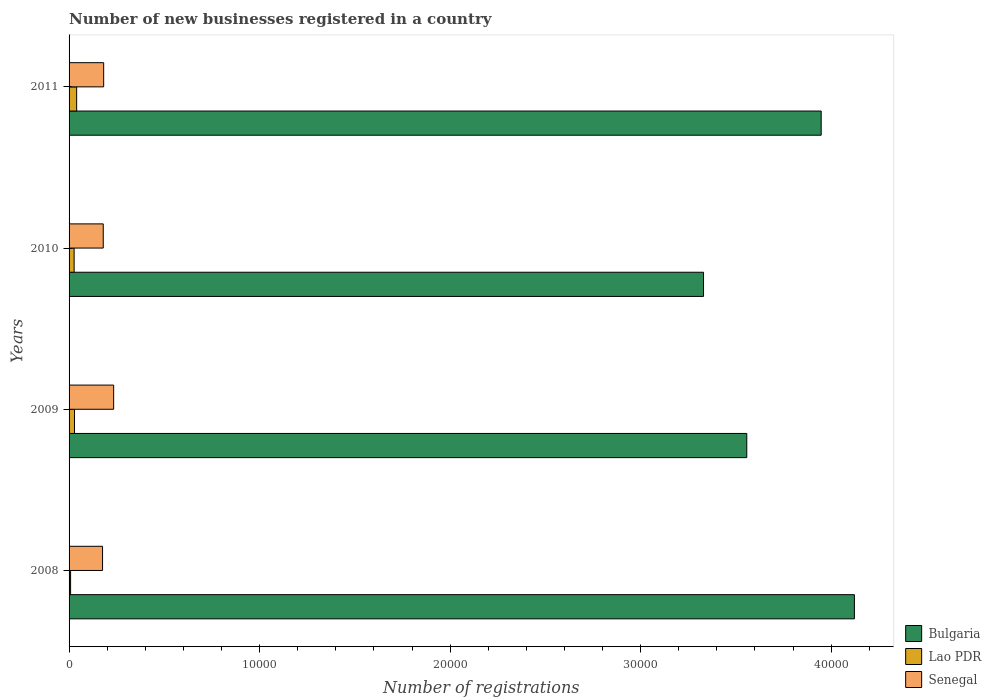How many different coloured bars are there?
Offer a very short reply. 3. How many groups of bars are there?
Your response must be concise. 4. Are the number of bars per tick equal to the number of legend labels?
Your answer should be very brief. Yes. Are the number of bars on each tick of the Y-axis equal?
Your answer should be compact. Yes. How many bars are there on the 2nd tick from the top?
Provide a short and direct response. 3. What is the label of the 3rd group of bars from the top?
Your answer should be compact. 2009. What is the number of new businesses registered in Lao PDR in 2010?
Provide a short and direct response. 265. Across all years, what is the maximum number of new businesses registered in Senegal?
Your answer should be very brief. 2340. In which year was the number of new businesses registered in Senegal maximum?
Ensure brevity in your answer.  2009. What is the total number of new businesses registered in Lao PDR in the graph?
Give a very brief answer. 1029. What is the difference between the number of new businesses registered in Senegal in 2008 and that in 2009?
Make the answer very short. -583. What is the difference between the number of new businesses registered in Bulgaria in 2010 and the number of new businesses registered in Senegal in 2008?
Offer a very short reply. 3.15e+04. What is the average number of new businesses registered in Bulgaria per year?
Your answer should be very brief. 3.74e+04. In the year 2009, what is the difference between the number of new businesses registered in Lao PDR and number of new businesses registered in Bulgaria?
Your answer should be compact. -3.53e+04. In how many years, is the number of new businesses registered in Bulgaria greater than 32000 ?
Make the answer very short. 4. What is the ratio of the number of new businesses registered in Lao PDR in 2008 to that in 2011?
Your answer should be compact. 0.2. Is the number of new businesses registered in Lao PDR in 2008 less than that in 2011?
Offer a very short reply. Yes. What is the difference between the highest and the second highest number of new businesses registered in Senegal?
Give a very brief answer. 524. What is the difference between the highest and the lowest number of new businesses registered in Bulgaria?
Ensure brevity in your answer.  7918. In how many years, is the number of new businesses registered in Bulgaria greater than the average number of new businesses registered in Bulgaria taken over all years?
Make the answer very short. 2. Is the sum of the number of new businesses registered in Senegal in 2010 and 2011 greater than the maximum number of new businesses registered in Bulgaria across all years?
Provide a succinct answer. No. What does the 2nd bar from the bottom in 2009 represents?
Your answer should be compact. Lao PDR. Is it the case that in every year, the sum of the number of new businesses registered in Lao PDR and number of new businesses registered in Senegal is greater than the number of new businesses registered in Bulgaria?
Make the answer very short. No. Are all the bars in the graph horizontal?
Make the answer very short. Yes. How many years are there in the graph?
Your response must be concise. 4. What is the difference between two consecutive major ticks on the X-axis?
Your answer should be very brief. 10000. Are the values on the major ticks of X-axis written in scientific E-notation?
Offer a terse response. No. Does the graph contain grids?
Keep it short and to the point. No. What is the title of the graph?
Your answer should be very brief. Number of new businesses registered in a country. What is the label or title of the X-axis?
Your answer should be very brief. Number of registrations. What is the Number of registrations of Bulgaria in 2008?
Offer a terse response. 4.12e+04. What is the Number of registrations of Senegal in 2008?
Make the answer very short. 1757. What is the Number of registrations in Bulgaria in 2009?
Ensure brevity in your answer.  3.56e+04. What is the Number of registrations of Lao PDR in 2009?
Offer a very short reply. 286. What is the Number of registrations of Senegal in 2009?
Ensure brevity in your answer.  2340. What is the Number of registrations in Bulgaria in 2010?
Your response must be concise. 3.33e+04. What is the Number of registrations in Lao PDR in 2010?
Provide a succinct answer. 265. What is the Number of registrations of Senegal in 2010?
Your response must be concise. 1794. What is the Number of registrations of Bulgaria in 2011?
Offer a very short reply. 3.95e+04. What is the Number of registrations of Lao PDR in 2011?
Your answer should be very brief. 398. What is the Number of registrations in Senegal in 2011?
Your response must be concise. 1816. Across all years, what is the maximum Number of registrations in Bulgaria?
Your response must be concise. 4.12e+04. Across all years, what is the maximum Number of registrations of Lao PDR?
Provide a succinct answer. 398. Across all years, what is the maximum Number of registrations of Senegal?
Provide a succinct answer. 2340. Across all years, what is the minimum Number of registrations in Bulgaria?
Provide a short and direct response. 3.33e+04. Across all years, what is the minimum Number of registrations in Lao PDR?
Give a very brief answer. 80. Across all years, what is the minimum Number of registrations in Senegal?
Offer a terse response. 1757. What is the total Number of registrations of Bulgaria in the graph?
Ensure brevity in your answer.  1.50e+05. What is the total Number of registrations of Lao PDR in the graph?
Offer a very short reply. 1029. What is the total Number of registrations of Senegal in the graph?
Make the answer very short. 7707. What is the difference between the Number of registrations of Bulgaria in 2008 and that in 2009?
Your answer should be very brief. 5648. What is the difference between the Number of registrations of Lao PDR in 2008 and that in 2009?
Provide a short and direct response. -206. What is the difference between the Number of registrations in Senegal in 2008 and that in 2009?
Make the answer very short. -583. What is the difference between the Number of registrations of Bulgaria in 2008 and that in 2010?
Your answer should be very brief. 7918. What is the difference between the Number of registrations of Lao PDR in 2008 and that in 2010?
Your answer should be compact. -185. What is the difference between the Number of registrations in Senegal in 2008 and that in 2010?
Provide a short and direct response. -37. What is the difference between the Number of registrations in Bulgaria in 2008 and that in 2011?
Offer a terse response. 1742. What is the difference between the Number of registrations in Lao PDR in 2008 and that in 2011?
Your answer should be compact. -318. What is the difference between the Number of registrations in Senegal in 2008 and that in 2011?
Your answer should be very brief. -59. What is the difference between the Number of registrations of Bulgaria in 2009 and that in 2010?
Provide a short and direct response. 2270. What is the difference between the Number of registrations in Senegal in 2009 and that in 2010?
Your answer should be very brief. 546. What is the difference between the Number of registrations in Bulgaria in 2009 and that in 2011?
Your response must be concise. -3906. What is the difference between the Number of registrations of Lao PDR in 2009 and that in 2011?
Offer a very short reply. -112. What is the difference between the Number of registrations in Senegal in 2009 and that in 2011?
Your answer should be very brief. 524. What is the difference between the Number of registrations in Bulgaria in 2010 and that in 2011?
Offer a very short reply. -6176. What is the difference between the Number of registrations of Lao PDR in 2010 and that in 2011?
Give a very brief answer. -133. What is the difference between the Number of registrations of Bulgaria in 2008 and the Number of registrations of Lao PDR in 2009?
Your answer should be very brief. 4.09e+04. What is the difference between the Number of registrations of Bulgaria in 2008 and the Number of registrations of Senegal in 2009?
Ensure brevity in your answer.  3.89e+04. What is the difference between the Number of registrations of Lao PDR in 2008 and the Number of registrations of Senegal in 2009?
Offer a very short reply. -2260. What is the difference between the Number of registrations of Bulgaria in 2008 and the Number of registrations of Lao PDR in 2010?
Ensure brevity in your answer.  4.10e+04. What is the difference between the Number of registrations of Bulgaria in 2008 and the Number of registrations of Senegal in 2010?
Offer a terse response. 3.94e+04. What is the difference between the Number of registrations of Lao PDR in 2008 and the Number of registrations of Senegal in 2010?
Keep it short and to the point. -1714. What is the difference between the Number of registrations in Bulgaria in 2008 and the Number of registrations in Lao PDR in 2011?
Ensure brevity in your answer.  4.08e+04. What is the difference between the Number of registrations in Bulgaria in 2008 and the Number of registrations in Senegal in 2011?
Your answer should be compact. 3.94e+04. What is the difference between the Number of registrations in Lao PDR in 2008 and the Number of registrations in Senegal in 2011?
Give a very brief answer. -1736. What is the difference between the Number of registrations of Bulgaria in 2009 and the Number of registrations of Lao PDR in 2010?
Keep it short and to the point. 3.53e+04. What is the difference between the Number of registrations in Bulgaria in 2009 and the Number of registrations in Senegal in 2010?
Give a very brief answer. 3.38e+04. What is the difference between the Number of registrations of Lao PDR in 2009 and the Number of registrations of Senegal in 2010?
Offer a very short reply. -1508. What is the difference between the Number of registrations of Bulgaria in 2009 and the Number of registrations of Lao PDR in 2011?
Ensure brevity in your answer.  3.52e+04. What is the difference between the Number of registrations of Bulgaria in 2009 and the Number of registrations of Senegal in 2011?
Offer a very short reply. 3.38e+04. What is the difference between the Number of registrations of Lao PDR in 2009 and the Number of registrations of Senegal in 2011?
Provide a short and direct response. -1530. What is the difference between the Number of registrations in Bulgaria in 2010 and the Number of registrations in Lao PDR in 2011?
Your response must be concise. 3.29e+04. What is the difference between the Number of registrations of Bulgaria in 2010 and the Number of registrations of Senegal in 2011?
Your answer should be very brief. 3.15e+04. What is the difference between the Number of registrations of Lao PDR in 2010 and the Number of registrations of Senegal in 2011?
Give a very brief answer. -1551. What is the average Number of registrations in Bulgaria per year?
Keep it short and to the point. 3.74e+04. What is the average Number of registrations of Lao PDR per year?
Provide a succinct answer. 257.25. What is the average Number of registrations of Senegal per year?
Keep it short and to the point. 1926.75. In the year 2008, what is the difference between the Number of registrations of Bulgaria and Number of registrations of Lao PDR?
Provide a succinct answer. 4.11e+04. In the year 2008, what is the difference between the Number of registrations in Bulgaria and Number of registrations in Senegal?
Make the answer very short. 3.95e+04. In the year 2008, what is the difference between the Number of registrations in Lao PDR and Number of registrations in Senegal?
Give a very brief answer. -1677. In the year 2009, what is the difference between the Number of registrations of Bulgaria and Number of registrations of Lao PDR?
Your answer should be very brief. 3.53e+04. In the year 2009, what is the difference between the Number of registrations in Bulgaria and Number of registrations in Senegal?
Your answer should be very brief. 3.32e+04. In the year 2009, what is the difference between the Number of registrations of Lao PDR and Number of registrations of Senegal?
Offer a terse response. -2054. In the year 2010, what is the difference between the Number of registrations in Bulgaria and Number of registrations in Lao PDR?
Your answer should be very brief. 3.30e+04. In the year 2010, what is the difference between the Number of registrations in Bulgaria and Number of registrations in Senegal?
Keep it short and to the point. 3.15e+04. In the year 2010, what is the difference between the Number of registrations of Lao PDR and Number of registrations of Senegal?
Make the answer very short. -1529. In the year 2011, what is the difference between the Number of registrations in Bulgaria and Number of registrations in Lao PDR?
Give a very brief answer. 3.91e+04. In the year 2011, what is the difference between the Number of registrations of Bulgaria and Number of registrations of Senegal?
Ensure brevity in your answer.  3.77e+04. In the year 2011, what is the difference between the Number of registrations of Lao PDR and Number of registrations of Senegal?
Provide a short and direct response. -1418. What is the ratio of the Number of registrations in Bulgaria in 2008 to that in 2009?
Your answer should be very brief. 1.16. What is the ratio of the Number of registrations of Lao PDR in 2008 to that in 2009?
Your answer should be compact. 0.28. What is the ratio of the Number of registrations in Senegal in 2008 to that in 2009?
Give a very brief answer. 0.75. What is the ratio of the Number of registrations of Bulgaria in 2008 to that in 2010?
Offer a very short reply. 1.24. What is the ratio of the Number of registrations of Lao PDR in 2008 to that in 2010?
Provide a short and direct response. 0.3. What is the ratio of the Number of registrations in Senegal in 2008 to that in 2010?
Offer a terse response. 0.98. What is the ratio of the Number of registrations in Bulgaria in 2008 to that in 2011?
Ensure brevity in your answer.  1.04. What is the ratio of the Number of registrations in Lao PDR in 2008 to that in 2011?
Your answer should be compact. 0.2. What is the ratio of the Number of registrations in Senegal in 2008 to that in 2011?
Provide a short and direct response. 0.97. What is the ratio of the Number of registrations in Bulgaria in 2009 to that in 2010?
Offer a very short reply. 1.07. What is the ratio of the Number of registrations in Lao PDR in 2009 to that in 2010?
Your answer should be compact. 1.08. What is the ratio of the Number of registrations of Senegal in 2009 to that in 2010?
Offer a very short reply. 1.3. What is the ratio of the Number of registrations of Bulgaria in 2009 to that in 2011?
Keep it short and to the point. 0.9. What is the ratio of the Number of registrations in Lao PDR in 2009 to that in 2011?
Offer a very short reply. 0.72. What is the ratio of the Number of registrations of Senegal in 2009 to that in 2011?
Offer a terse response. 1.29. What is the ratio of the Number of registrations in Bulgaria in 2010 to that in 2011?
Your response must be concise. 0.84. What is the ratio of the Number of registrations in Lao PDR in 2010 to that in 2011?
Your response must be concise. 0.67. What is the ratio of the Number of registrations of Senegal in 2010 to that in 2011?
Offer a terse response. 0.99. What is the difference between the highest and the second highest Number of registrations in Bulgaria?
Your answer should be very brief. 1742. What is the difference between the highest and the second highest Number of registrations of Lao PDR?
Your answer should be compact. 112. What is the difference between the highest and the second highest Number of registrations of Senegal?
Your answer should be compact. 524. What is the difference between the highest and the lowest Number of registrations of Bulgaria?
Provide a succinct answer. 7918. What is the difference between the highest and the lowest Number of registrations of Lao PDR?
Provide a short and direct response. 318. What is the difference between the highest and the lowest Number of registrations of Senegal?
Your answer should be compact. 583. 